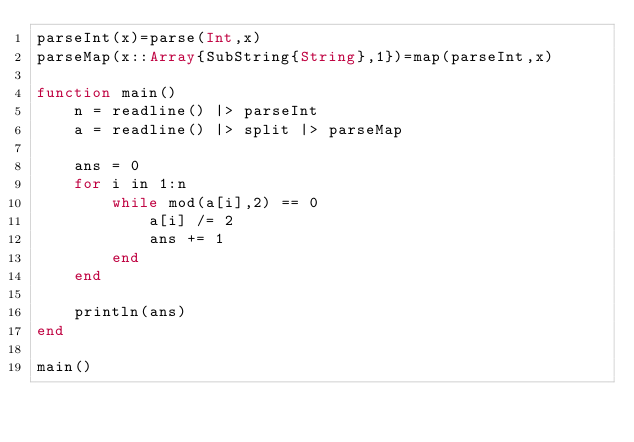Convert code to text. <code><loc_0><loc_0><loc_500><loc_500><_Julia_>parseInt(x)=parse(Int,x)
parseMap(x::Array{SubString{String},1})=map(parseInt,x)

function main()
    n = readline() |> parseInt
    a = readline() |> split |> parseMap

    ans = 0
    for i in 1:n
        while mod(a[i],2) == 0
            a[i] /= 2
            ans += 1
        end
    end

    println(ans)
end

main()
</code> 